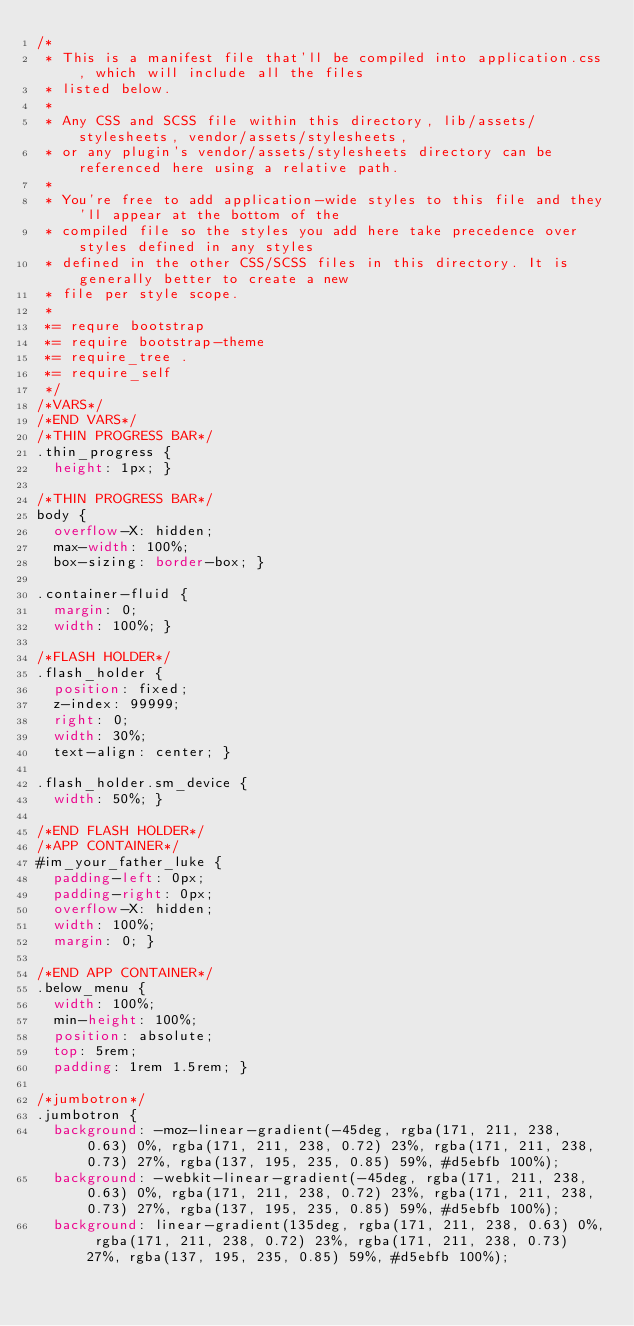<code> <loc_0><loc_0><loc_500><loc_500><_CSS_>/*
 * This is a manifest file that'll be compiled into application.css, which will include all the files
 * listed below. 
 *
 * Any CSS and SCSS file within this directory, lib/assets/stylesheets, vendor/assets/stylesheets,
 * or any plugin's vendor/assets/stylesheets directory can be referenced here using a relative path.
 *
 * You're free to add application-wide styles to this file and they'll appear at the bottom of the
 * compiled file so the styles you add here take precedence over styles defined in any styles
 * defined in the other CSS/SCSS files in this directory. It is generally better to create a new
 * file per style scope.
 *
 *= requre bootstrap
 *= require bootstrap-theme
 *= require_tree .
 *= require_self
 */
/*VARS*/
/*END VARS*/
/*THIN PROGRESS BAR*/
.thin_progress {
  height: 1px; }

/*THIN PROGRESS BAR*/
body {
  overflow-X: hidden;
  max-width: 100%;
  box-sizing: border-box; }

.container-fluid {
  margin: 0;
  width: 100%; }

/*FLASH HOLDER*/
.flash_holder {
  position: fixed;
  z-index: 99999;
  right: 0;
  width: 30%;
  text-align: center; }

.flash_holder.sm_device {
  width: 50%; }

/*END FLASH HOLDER*/
/*APP CONTAINER*/
#im_your_father_luke {
  padding-left: 0px;
  padding-right: 0px;
  overflow-X: hidden;
  width: 100%;
  margin: 0; }

/*END APP CONTAINER*/
.below_menu {
  width: 100%;
  min-height: 100%;
  position: absolute;
  top: 5rem;
  padding: 1rem 1.5rem; }

/*jumbotron*/
.jumbotron {
  background: -moz-linear-gradient(-45deg, rgba(171, 211, 238, 0.63) 0%, rgba(171, 211, 238, 0.72) 23%, rgba(171, 211, 238, 0.73) 27%, rgba(137, 195, 235, 0.85) 59%, #d5ebfb 100%);
  background: -webkit-linear-gradient(-45deg, rgba(171, 211, 238, 0.63) 0%, rgba(171, 211, 238, 0.72) 23%, rgba(171, 211, 238, 0.73) 27%, rgba(137, 195, 235, 0.85) 59%, #d5ebfb 100%);
  background: linear-gradient(135deg, rgba(171, 211, 238, 0.63) 0%, rgba(171, 211, 238, 0.72) 23%, rgba(171, 211, 238, 0.73) 27%, rgba(137, 195, 235, 0.85) 59%, #d5ebfb 100%);</code> 